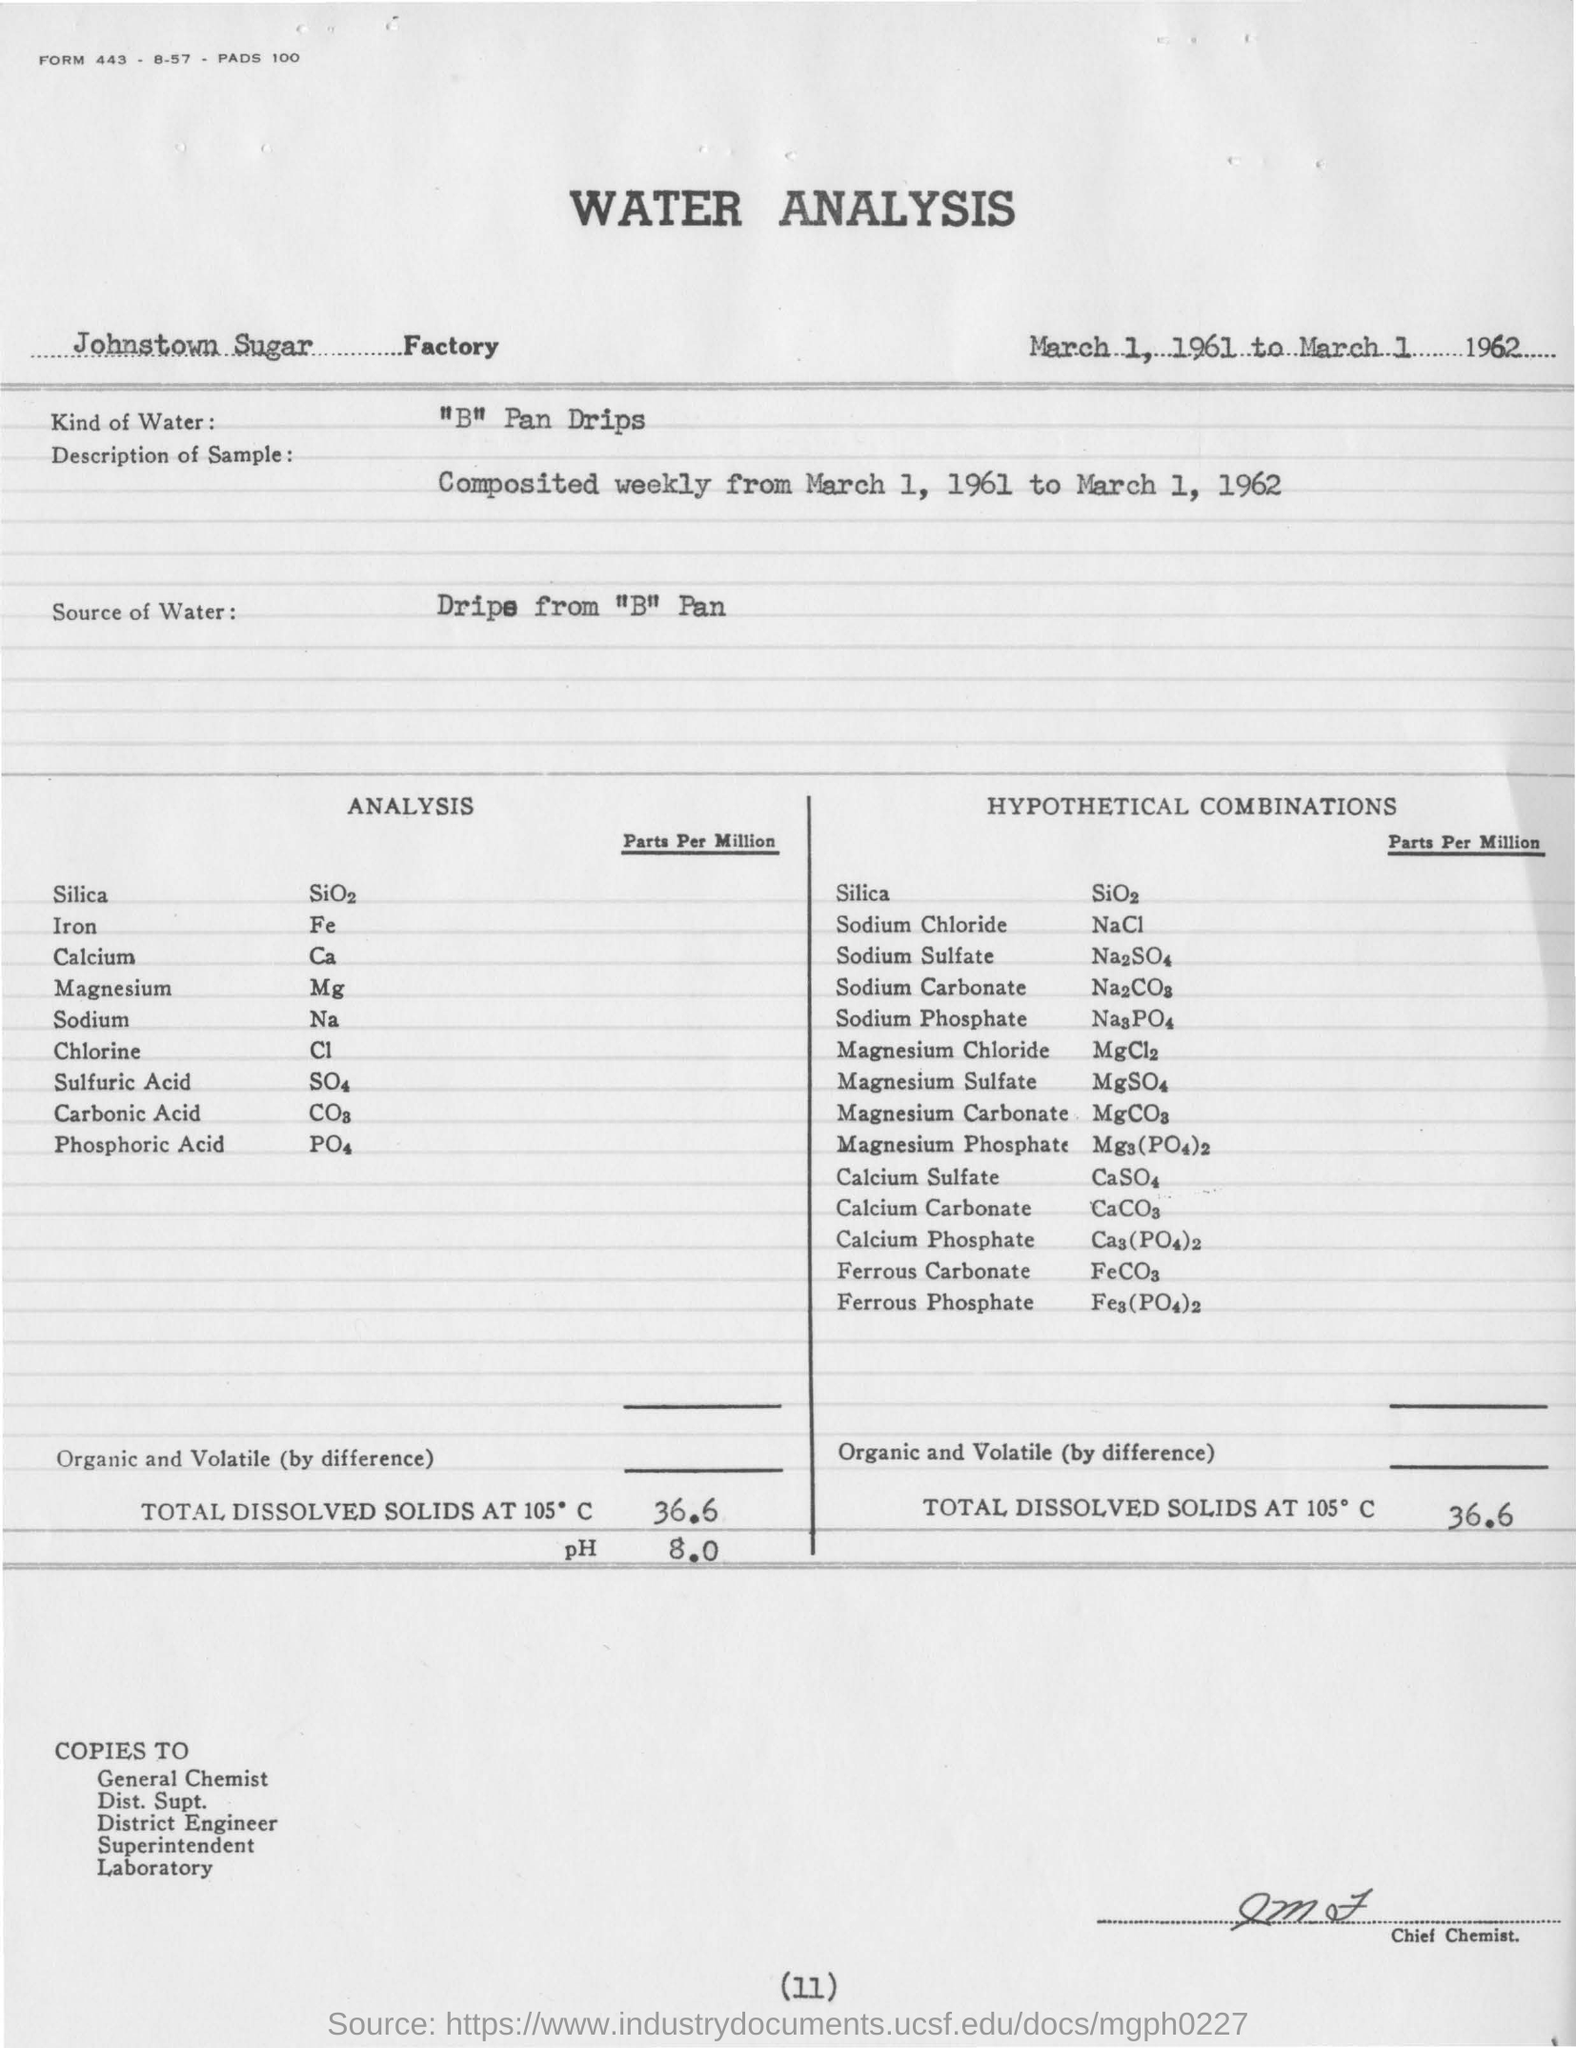Draw attention to some important aspects in this diagram. The samples were collected over a period of one year, from March 1, 1961 to March 1, 1962, and were composited on a weekly basis. B" refers to "boiling point" which is not a type of water used in water analysis. Therefore, the correct answer is "A" distilled water. The pH value is 8.0. 